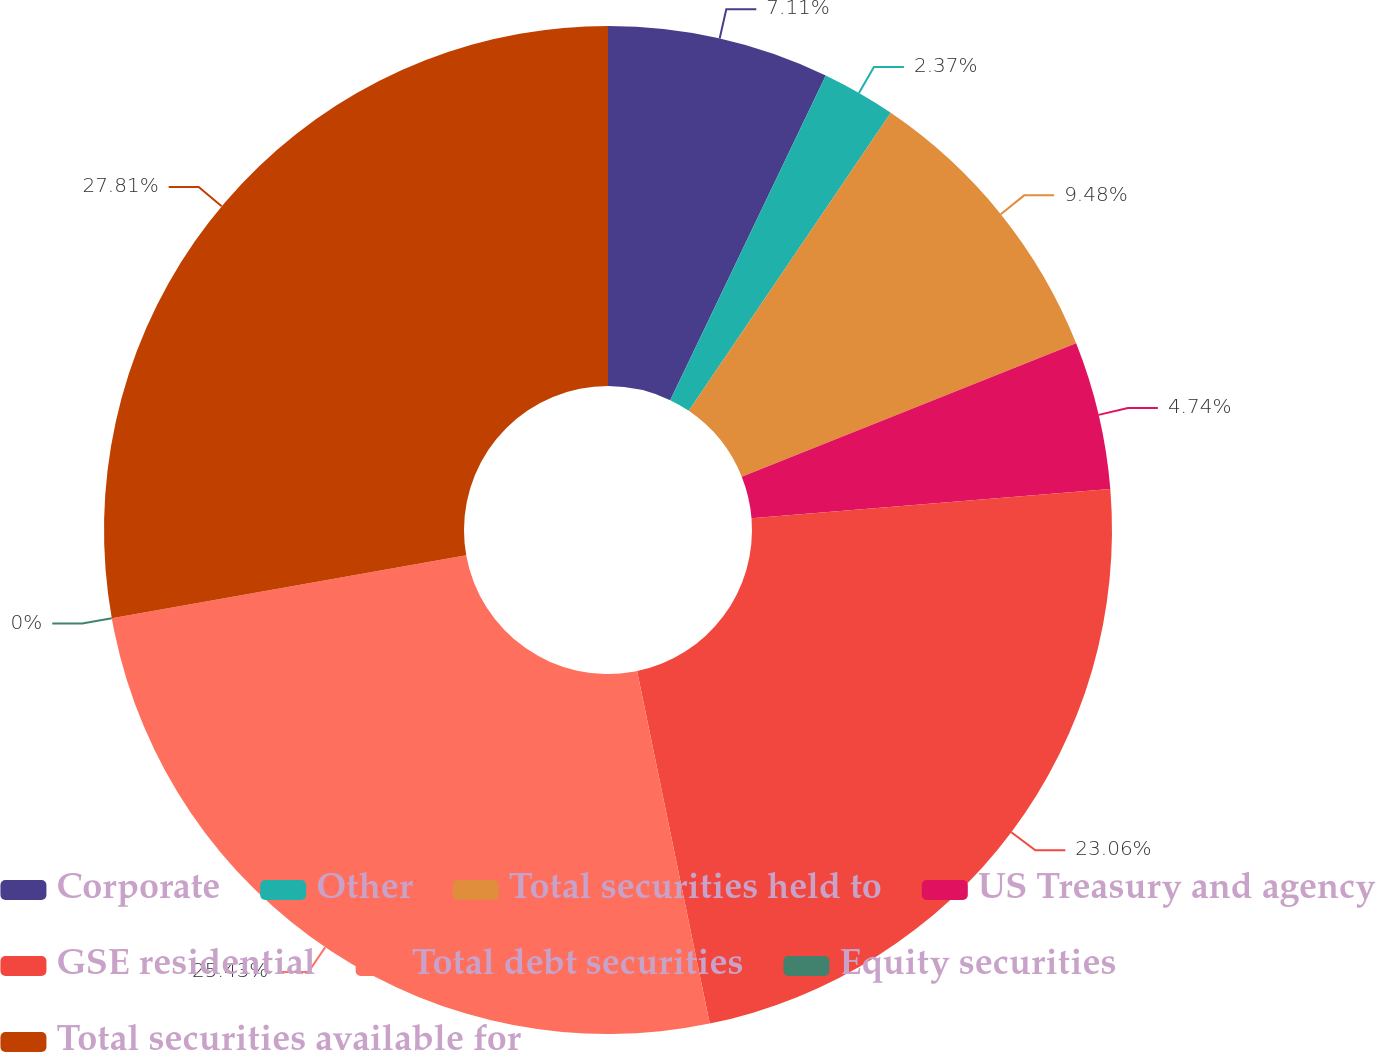Convert chart to OTSL. <chart><loc_0><loc_0><loc_500><loc_500><pie_chart><fcel>Corporate<fcel>Other<fcel>Total securities held to<fcel>US Treasury and agency<fcel>GSE residential<fcel>Total debt securities<fcel>Equity securities<fcel>Total securities available for<nl><fcel>7.11%<fcel>2.37%<fcel>9.48%<fcel>4.74%<fcel>23.06%<fcel>25.43%<fcel>0.0%<fcel>27.8%<nl></chart> 